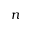Convert formula to latex. <formula><loc_0><loc_0><loc_500><loc_500>n</formula> 